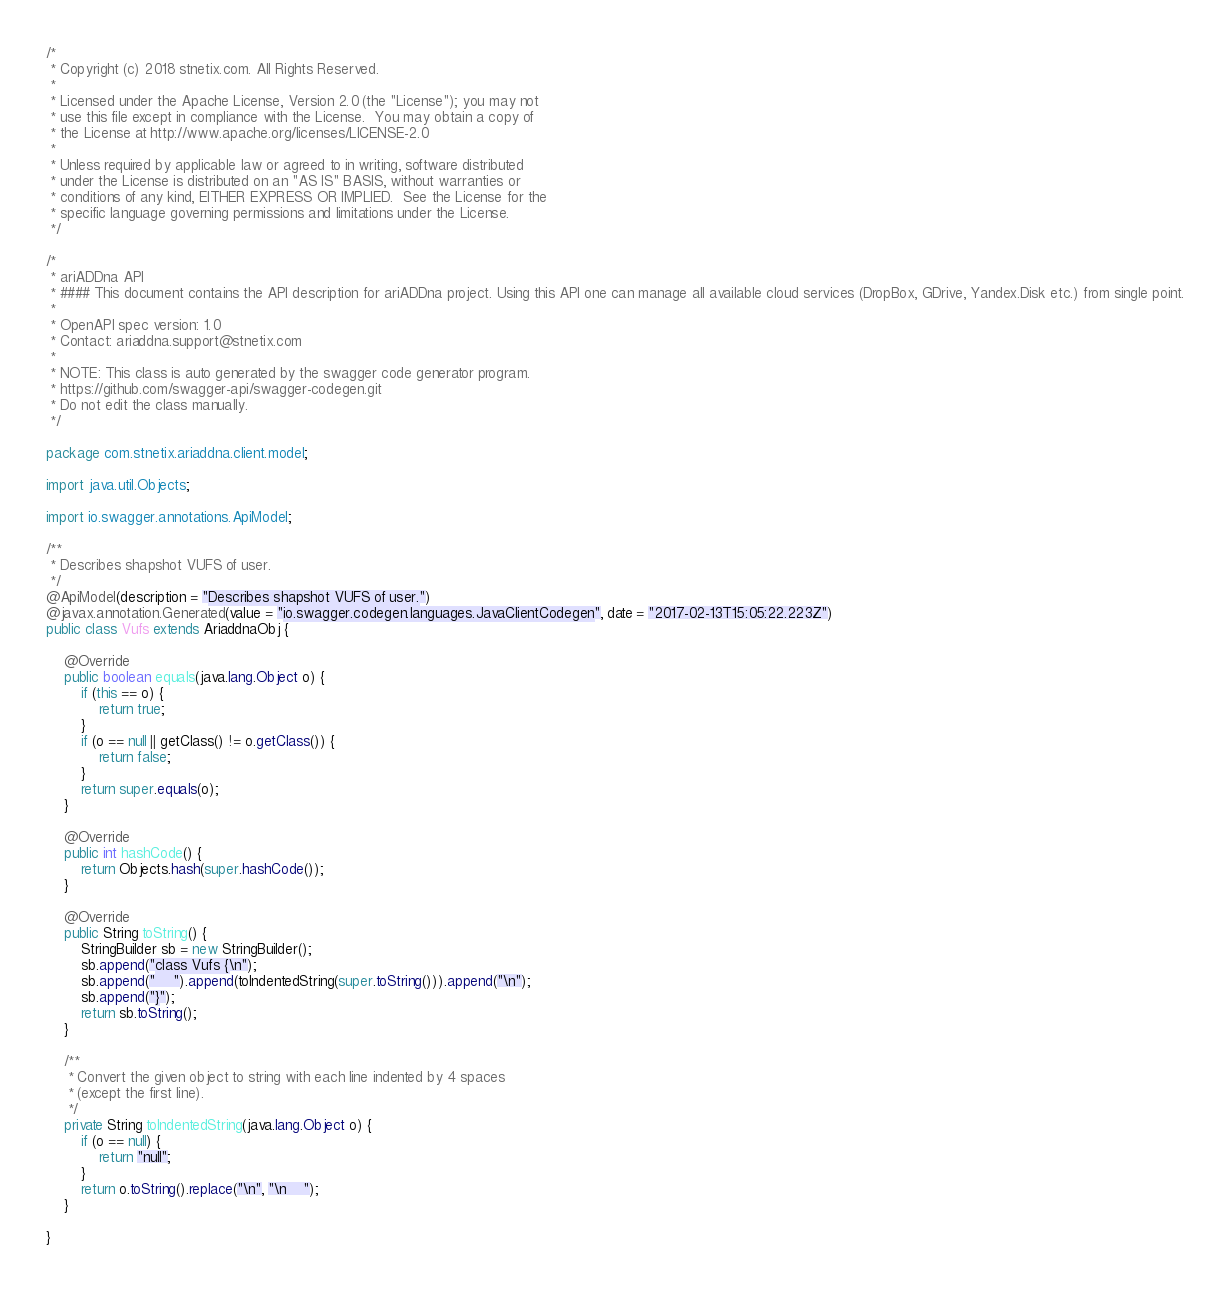Convert code to text. <code><loc_0><loc_0><loc_500><loc_500><_Java_>/*
 * Copyright (c) 2018 stnetix.com. All Rights Reserved.
 *
 * Licensed under the Apache License, Version 2.0 (the "License"); you may not
 * use this file except in compliance with the License.  You may obtain a copy of
 * the License at http://www.apache.org/licenses/LICENSE-2.0
 *
 * Unless required by applicable law or agreed to in writing, software distributed
 * under the License is distributed on an "AS IS" BASIS, without warranties or
 * conditions of any kind, EITHER EXPRESS OR IMPLIED.  See the License for the
 * specific language governing permissions and limitations under the License.
 */

/*
 * ariADDna API
 * #### This document contains the API description for ariADDna project. Using this API one can manage all available cloud services (DropBox, GDrive, Yandex.Disk etc.) from single point.
 *
 * OpenAPI spec version: 1.0
 * Contact: ariaddna.support@stnetix.com
 *
 * NOTE: This class is auto generated by the swagger code generator program.
 * https://github.com/swagger-api/swagger-codegen.git
 * Do not edit the class manually.
 */

package com.stnetix.ariaddna.client.model;

import java.util.Objects;

import io.swagger.annotations.ApiModel;

/**
 * Describes shapshot VUFS of user.
 */
@ApiModel(description = "Describes shapshot VUFS of user.")
@javax.annotation.Generated(value = "io.swagger.codegen.languages.JavaClientCodegen", date = "2017-02-13T15:05:22.223Z")
public class Vufs extends AriaddnaObj {

    @Override
    public boolean equals(java.lang.Object o) {
        if (this == o) {
            return true;
        }
        if (o == null || getClass() != o.getClass()) {
            return false;
        }
        return super.equals(o);
    }

    @Override
    public int hashCode() {
        return Objects.hash(super.hashCode());
    }

    @Override
    public String toString() {
        StringBuilder sb = new StringBuilder();
        sb.append("class Vufs {\n");
        sb.append("    ").append(toIndentedString(super.toString())).append("\n");
        sb.append("}");
        return sb.toString();
    }

    /**
     * Convert the given object to string with each line indented by 4 spaces
     * (except the first line).
     */
    private String toIndentedString(java.lang.Object o) {
        if (o == null) {
            return "null";
        }
        return o.toString().replace("\n", "\n    ");
    }

}

</code> 